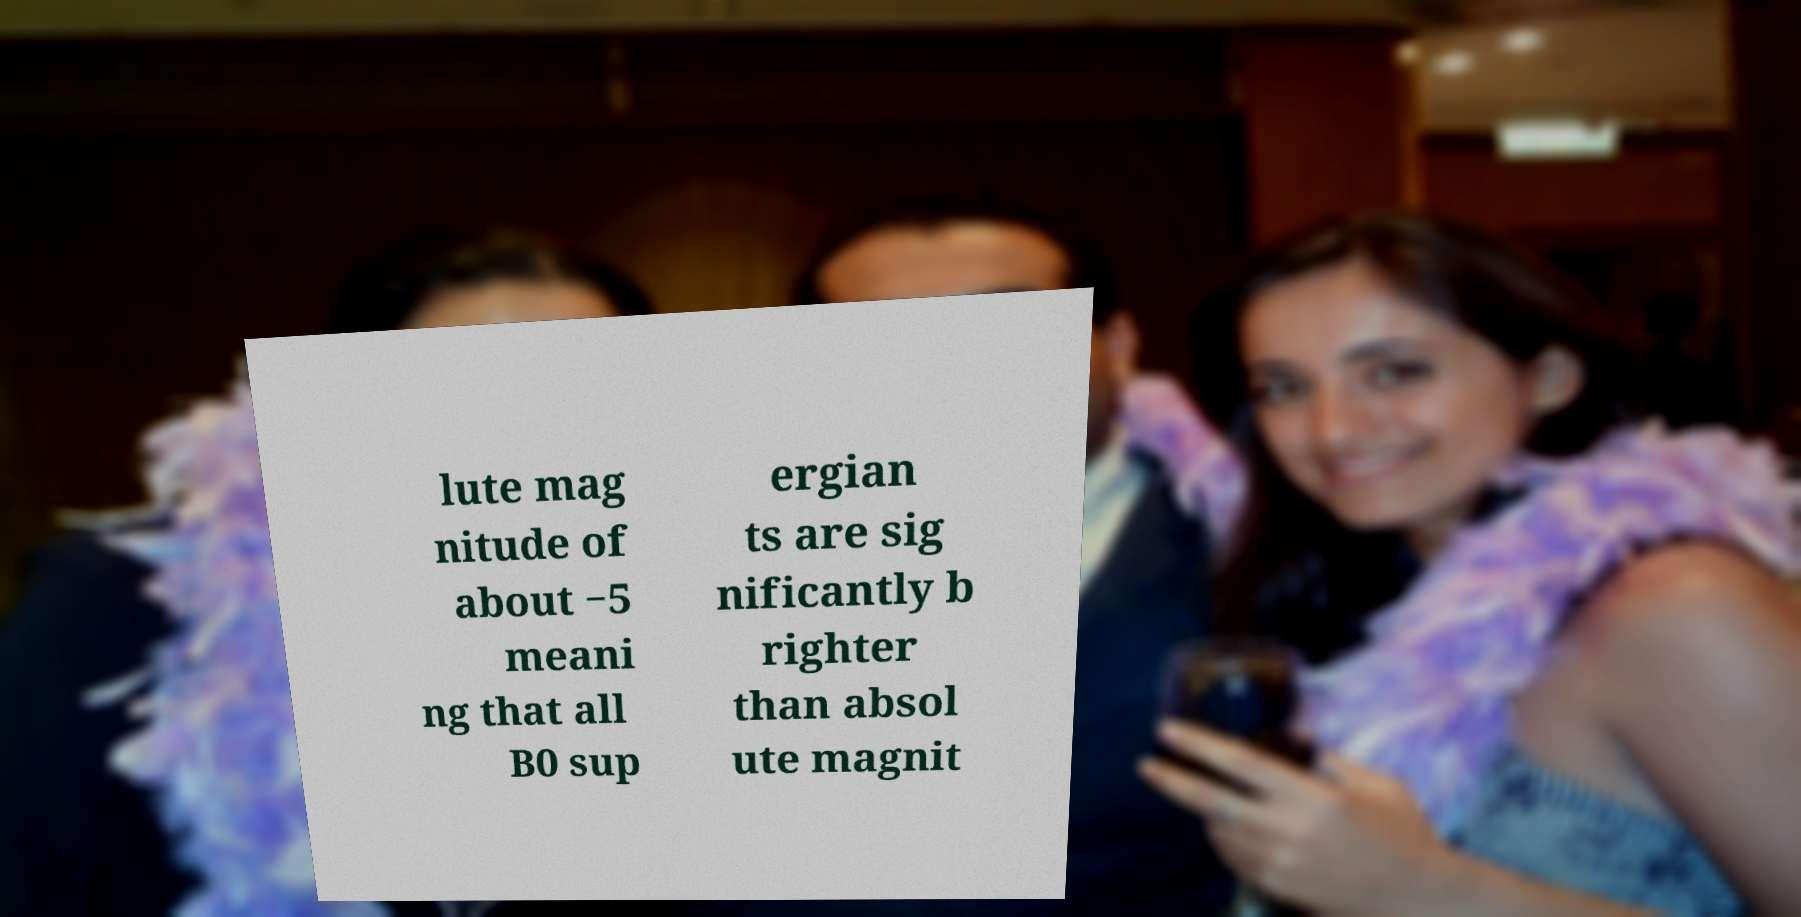I need the written content from this picture converted into text. Can you do that? lute mag nitude of about −5 meani ng that all B0 sup ergian ts are sig nificantly b righter than absol ute magnit 